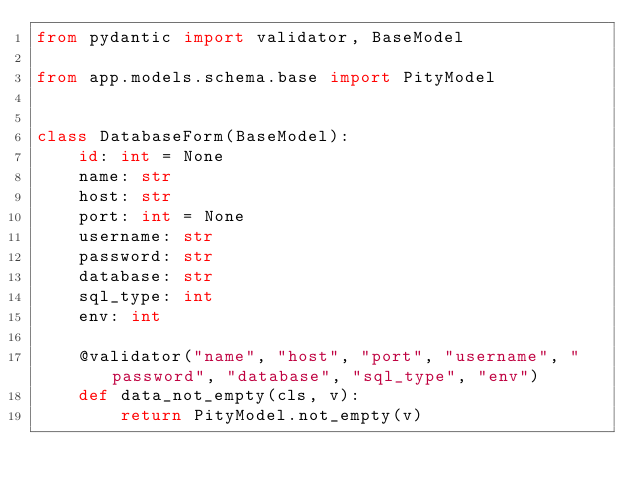Convert code to text. <code><loc_0><loc_0><loc_500><loc_500><_Python_>from pydantic import validator, BaseModel

from app.models.schema.base import PityModel


class DatabaseForm(BaseModel):
    id: int = None
    name: str
    host: str
    port: int = None
    username: str
    password: str
    database: str
    sql_type: int
    env: int

    @validator("name", "host", "port", "username", "password", "database", "sql_type", "env")
    def data_not_empty(cls, v):
        return PityModel.not_empty(v)
</code> 